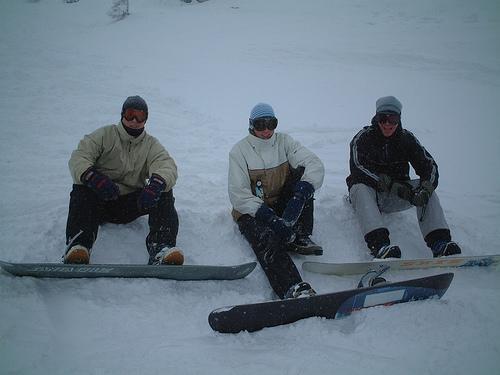How many people are pictured?
Give a very brief answer. 3. How many people are there?
Give a very brief answer. 3. How many feet aren't on a board?
Give a very brief answer. 1. How many snowboards are there?
Give a very brief answer. 2. How many people are visible?
Give a very brief answer. 3. 